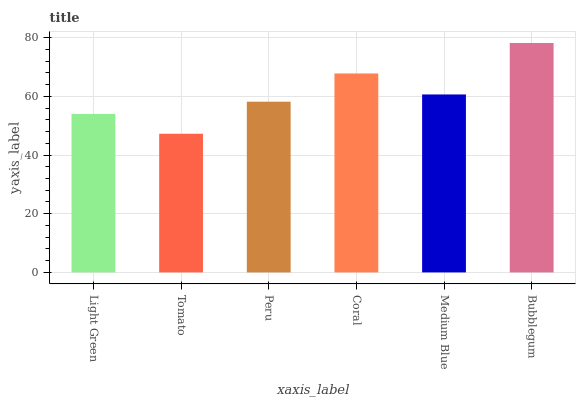Is Peru the minimum?
Answer yes or no. No. Is Peru the maximum?
Answer yes or no. No. Is Peru greater than Tomato?
Answer yes or no. Yes. Is Tomato less than Peru?
Answer yes or no. Yes. Is Tomato greater than Peru?
Answer yes or no. No. Is Peru less than Tomato?
Answer yes or no. No. Is Medium Blue the high median?
Answer yes or no. Yes. Is Peru the low median?
Answer yes or no. Yes. Is Coral the high median?
Answer yes or no. No. Is Tomato the low median?
Answer yes or no. No. 